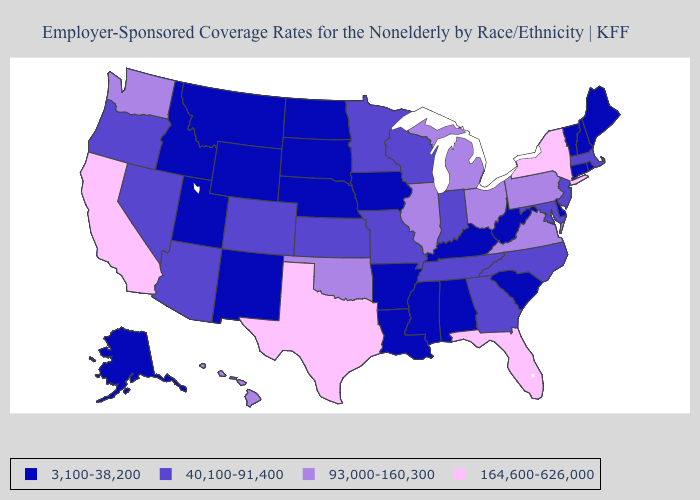What is the value of Illinois?
Short answer required. 93,000-160,300. What is the value of Arkansas?
Answer briefly. 3,100-38,200. What is the highest value in the West ?
Quick response, please. 164,600-626,000. Does the map have missing data?
Concise answer only. No. What is the highest value in the MidWest ?
Concise answer only. 93,000-160,300. What is the highest value in the West ?
Concise answer only. 164,600-626,000. Does Arkansas have the same value as Rhode Island?
Concise answer only. Yes. What is the value of Wyoming?
Keep it brief. 3,100-38,200. Does Nevada have the same value as Rhode Island?
Be succinct. No. Name the states that have a value in the range 93,000-160,300?
Give a very brief answer. Hawaii, Illinois, Michigan, Ohio, Oklahoma, Pennsylvania, Virginia, Washington. Does Louisiana have a lower value than Arkansas?
Concise answer only. No. Name the states that have a value in the range 40,100-91,400?
Short answer required. Arizona, Colorado, Georgia, Indiana, Kansas, Maryland, Massachusetts, Minnesota, Missouri, Nevada, New Jersey, North Carolina, Oregon, Tennessee, Wisconsin. Name the states that have a value in the range 164,600-626,000?
Concise answer only. California, Florida, New York, Texas. What is the highest value in states that border Michigan?
Quick response, please. 93,000-160,300. 